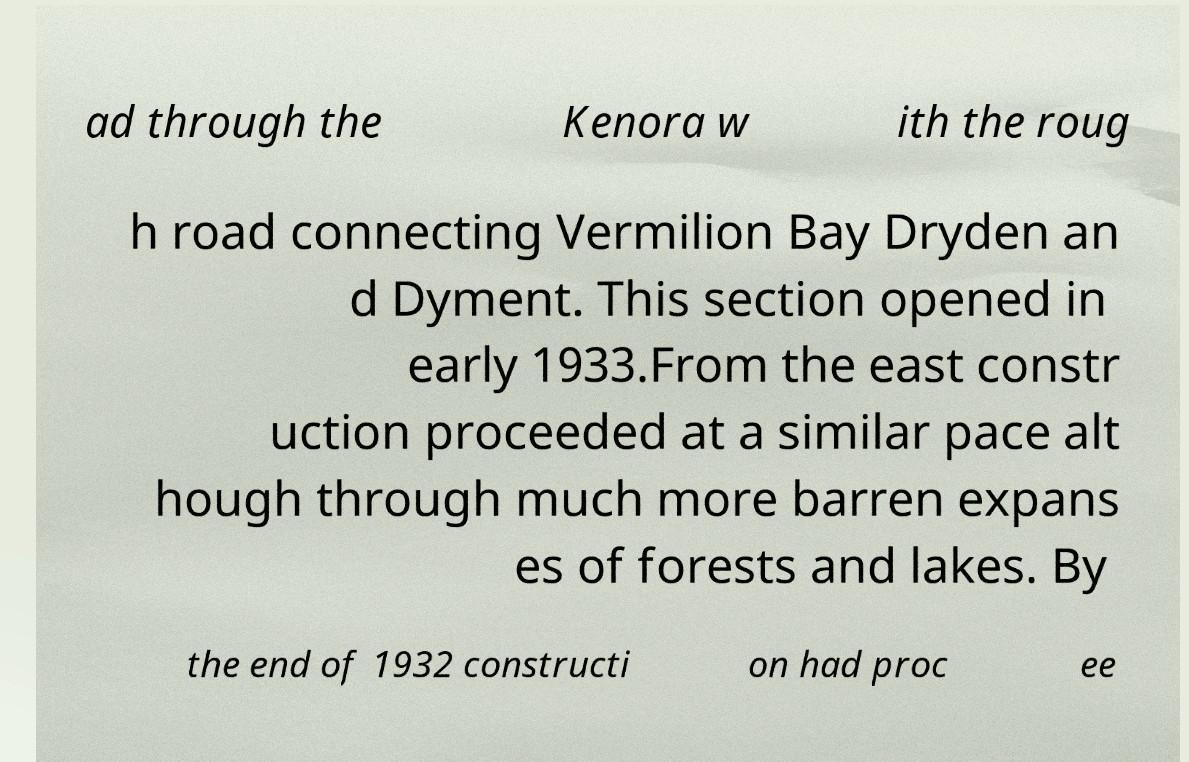Can you accurately transcribe the text from the provided image for me? ad through the Kenora w ith the roug h road connecting Vermilion Bay Dryden an d Dyment. This section opened in early 1933.From the east constr uction proceeded at a similar pace alt hough through much more barren expans es of forests and lakes. By the end of 1932 constructi on had proc ee 